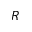<formula> <loc_0><loc_0><loc_500><loc_500>R</formula> 